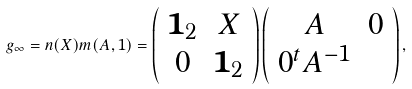<formula> <loc_0><loc_0><loc_500><loc_500>g _ { \infty } = n ( X ) m ( A , 1 ) = \left ( \begin{array} { c c } \mathbf 1 _ { 2 } & X \\ 0 & \mathbf 1 _ { 2 } \end{array} \right ) \left ( \begin{array} { c c } A & 0 \\ 0 ^ { t } A ^ { - 1 } \end{array} \right ) ,</formula> 